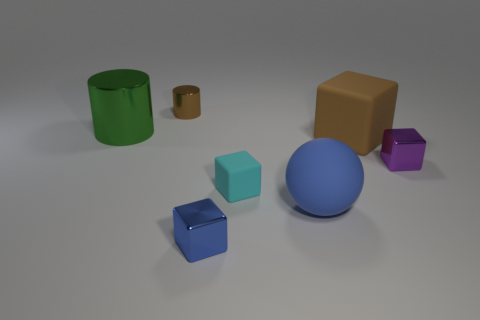Subtract all yellow blocks. Subtract all blue spheres. How many blocks are left? 4 Add 1 tiny gray blocks. How many objects exist? 8 Subtract all cylinders. How many objects are left? 5 Add 3 blue rubber spheres. How many blue rubber spheres exist? 4 Subtract 1 blue blocks. How many objects are left? 6 Subtract all small purple things. Subtract all small yellow matte blocks. How many objects are left? 6 Add 5 small brown objects. How many small brown objects are left? 6 